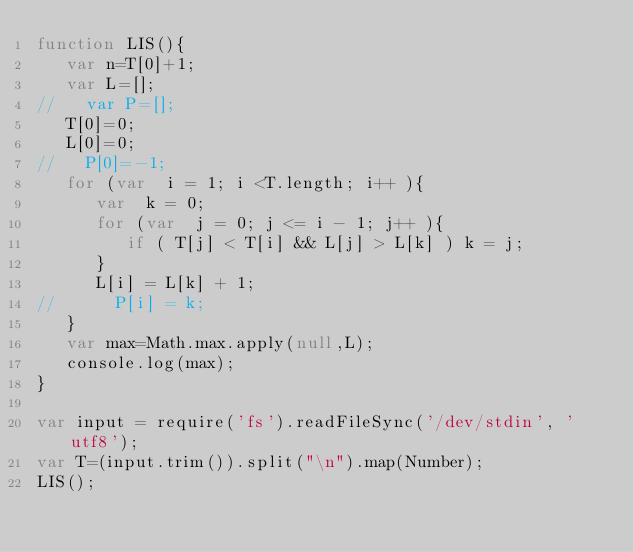<code> <loc_0><loc_0><loc_500><loc_500><_JavaScript_>function LIS(){
   var n=T[0]+1;
   var L=[];
//   var P=[];
   T[0]=0;
   L[0]=0;
//   P[0]=-1;
   for (var  i = 1; i <T.length; i++ ){
      var  k = 0;
      for (var  j = 0; j <= i - 1; j++ ){
         if ( T[j] < T[i] && L[j] > L[k] ) k = j;
      }
      L[i] = L[k] + 1;
//      P[i] = k;
   }
   var max=Math.max.apply(null,L);
   console.log(max);
}

var input = require('fs').readFileSync('/dev/stdin', 'utf8');
var T=(input.trim()).split("\n").map(Number);
LIS();</code> 